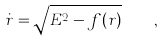Convert formula to latex. <formula><loc_0><loc_0><loc_500><loc_500>\dot { r } = \sqrt { E ^ { 2 } - f ( r ) } \quad ,</formula> 